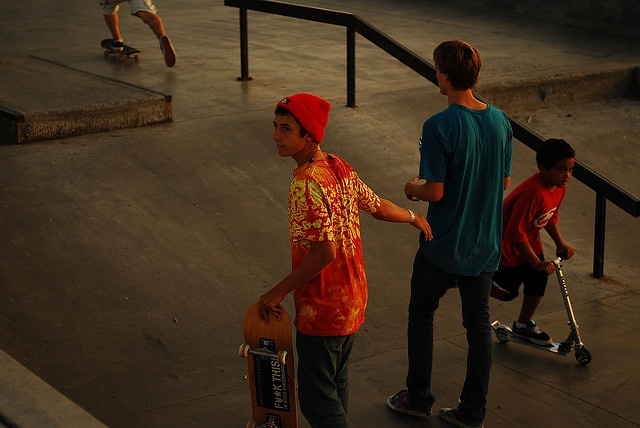Describe the objects in this image and their specific colors. I can see people in black, maroon, and teal tones, people in black, maroon, and brown tones, people in black and maroon tones, skateboard in black, maroon, olive, and gray tones, and people in black, gray, maroon, and brown tones in this image. 